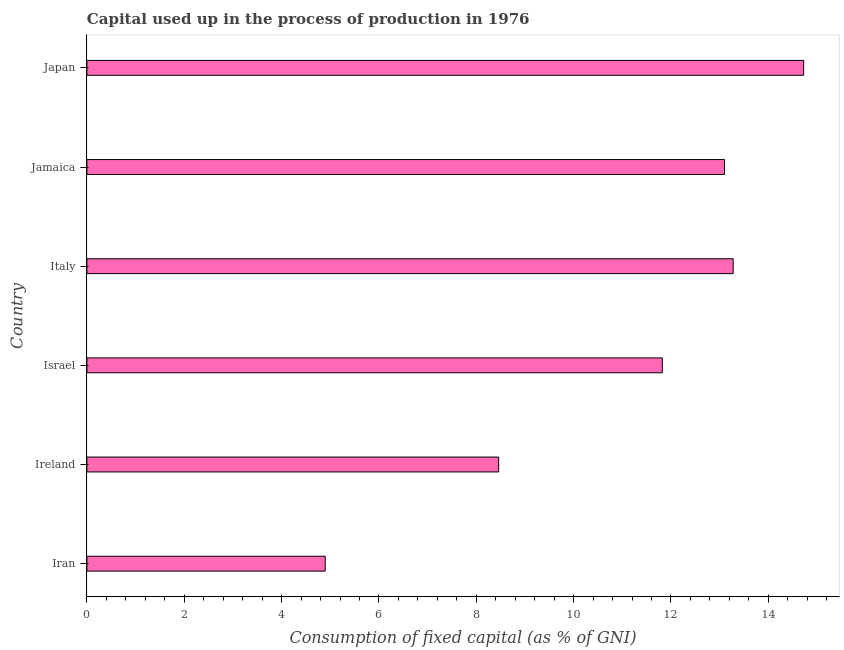What is the title of the graph?
Ensure brevity in your answer.  Capital used up in the process of production in 1976. What is the label or title of the X-axis?
Provide a succinct answer. Consumption of fixed capital (as % of GNI). What is the consumption of fixed capital in Ireland?
Your answer should be compact. 8.46. Across all countries, what is the maximum consumption of fixed capital?
Provide a succinct answer. 14.73. Across all countries, what is the minimum consumption of fixed capital?
Offer a very short reply. 4.9. In which country was the consumption of fixed capital minimum?
Offer a very short reply. Iran. What is the sum of the consumption of fixed capital?
Provide a short and direct response. 66.28. What is the difference between the consumption of fixed capital in Jamaica and Japan?
Your answer should be very brief. -1.62. What is the average consumption of fixed capital per country?
Provide a succinct answer. 11.05. What is the median consumption of fixed capital?
Your answer should be compact. 12.46. In how many countries, is the consumption of fixed capital greater than 8 %?
Your response must be concise. 5. What is the ratio of the consumption of fixed capital in Italy to that in Japan?
Make the answer very short. 0.9. Is the difference between the consumption of fixed capital in Iran and Japan greater than the difference between any two countries?
Your answer should be compact. Yes. What is the difference between the highest and the second highest consumption of fixed capital?
Keep it short and to the point. 1.45. What is the difference between the highest and the lowest consumption of fixed capital?
Your response must be concise. 9.83. Are the values on the major ticks of X-axis written in scientific E-notation?
Provide a succinct answer. No. What is the Consumption of fixed capital (as % of GNI) in Iran?
Keep it short and to the point. 4.9. What is the Consumption of fixed capital (as % of GNI) in Ireland?
Provide a short and direct response. 8.46. What is the Consumption of fixed capital (as % of GNI) in Israel?
Provide a succinct answer. 11.82. What is the Consumption of fixed capital (as % of GNI) in Italy?
Keep it short and to the point. 13.28. What is the Consumption of fixed capital (as % of GNI) of Jamaica?
Keep it short and to the point. 13.1. What is the Consumption of fixed capital (as % of GNI) in Japan?
Offer a very short reply. 14.73. What is the difference between the Consumption of fixed capital (as % of GNI) in Iran and Ireland?
Provide a short and direct response. -3.56. What is the difference between the Consumption of fixed capital (as % of GNI) in Iran and Israel?
Your response must be concise. -6.93. What is the difference between the Consumption of fixed capital (as % of GNI) in Iran and Italy?
Your answer should be compact. -8.38. What is the difference between the Consumption of fixed capital (as % of GNI) in Iran and Jamaica?
Provide a short and direct response. -8.2. What is the difference between the Consumption of fixed capital (as % of GNI) in Iran and Japan?
Your answer should be very brief. -9.83. What is the difference between the Consumption of fixed capital (as % of GNI) in Ireland and Israel?
Your answer should be very brief. -3.36. What is the difference between the Consumption of fixed capital (as % of GNI) in Ireland and Italy?
Your response must be concise. -4.82. What is the difference between the Consumption of fixed capital (as % of GNI) in Ireland and Jamaica?
Offer a very short reply. -4.64. What is the difference between the Consumption of fixed capital (as % of GNI) in Ireland and Japan?
Keep it short and to the point. -6.27. What is the difference between the Consumption of fixed capital (as % of GNI) in Israel and Italy?
Provide a succinct answer. -1.46. What is the difference between the Consumption of fixed capital (as % of GNI) in Israel and Jamaica?
Your answer should be very brief. -1.28. What is the difference between the Consumption of fixed capital (as % of GNI) in Israel and Japan?
Your response must be concise. -2.9. What is the difference between the Consumption of fixed capital (as % of GNI) in Italy and Jamaica?
Your answer should be very brief. 0.18. What is the difference between the Consumption of fixed capital (as % of GNI) in Italy and Japan?
Your answer should be very brief. -1.45. What is the difference between the Consumption of fixed capital (as % of GNI) in Jamaica and Japan?
Give a very brief answer. -1.63. What is the ratio of the Consumption of fixed capital (as % of GNI) in Iran to that in Ireland?
Provide a short and direct response. 0.58. What is the ratio of the Consumption of fixed capital (as % of GNI) in Iran to that in Israel?
Make the answer very short. 0.41. What is the ratio of the Consumption of fixed capital (as % of GNI) in Iran to that in Italy?
Keep it short and to the point. 0.37. What is the ratio of the Consumption of fixed capital (as % of GNI) in Iran to that in Jamaica?
Offer a very short reply. 0.37. What is the ratio of the Consumption of fixed capital (as % of GNI) in Iran to that in Japan?
Provide a succinct answer. 0.33. What is the ratio of the Consumption of fixed capital (as % of GNI) in Ireland to that in Israel?
Ensure brevity in your answer.  0.72. What is the ratio of the Consumption of fixed capital (as % of GNI) in Ireland to that in Italy?
Provide a short and direct response. 0.64. What is the ratio of the Consumption of fixed capital (as % of GNI) in Ireland to that in Jamaica?
Offer a terse response. 0.65. What is the ratio of the Consumption of fixed capital (as % of GNI) in Ireland to that in Japan?
Give a very brief answer. 0.57. What is the ratio of the Consumption of fixed capital (as % of GNI) in Israel to that in Italy?
Give a very brief answer. 0.89. What is the ratio of the Consumption of fixed capital (as % of GNI) in Israel to that in Jamaica?
Make the answer very short. 0.9. What is the ratio of the Consumption of fixed capital (as % of GNI) in Israel to that in Japan?
Your response must be concise. 0.8. What is the ratio of the Consumption of fixed capital (as % of GNI) in Italy to that in Japan?
Ensure brevity in your answer.  0.9. What is the ratio of the Consumption of fixed capital (as % of GNI) in Jamaica to that in Japan?
Offer a very short reply. 0.89. 